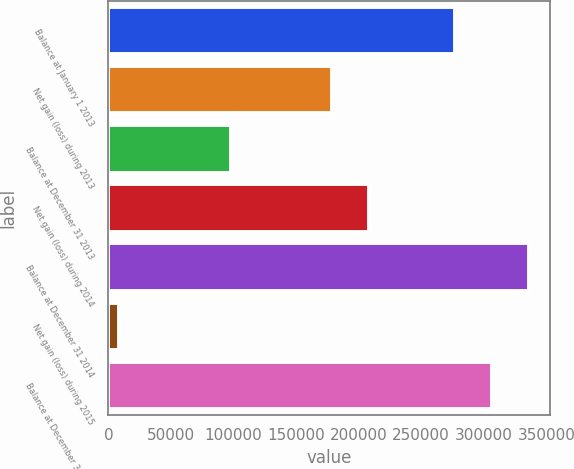<chart> <loc_0><loc_0><loc_500><loc_500><bar_chart><fcel>Balance at January 1 2013<fcel>Net gain (loss) during 2013<fcel>Balance at December 31 2013<fcel>Net gain (loss) during 2014<fcel>Balance at December 31 2014<fcel>Net gain (loss) during 2015<fcel>Balance at December 31 2015<nl><fcel>276771<fcel>178589<fcel>98182<fcel>208287<fcel>336167<fcel>8610<fcel>306469<nl></chart> 